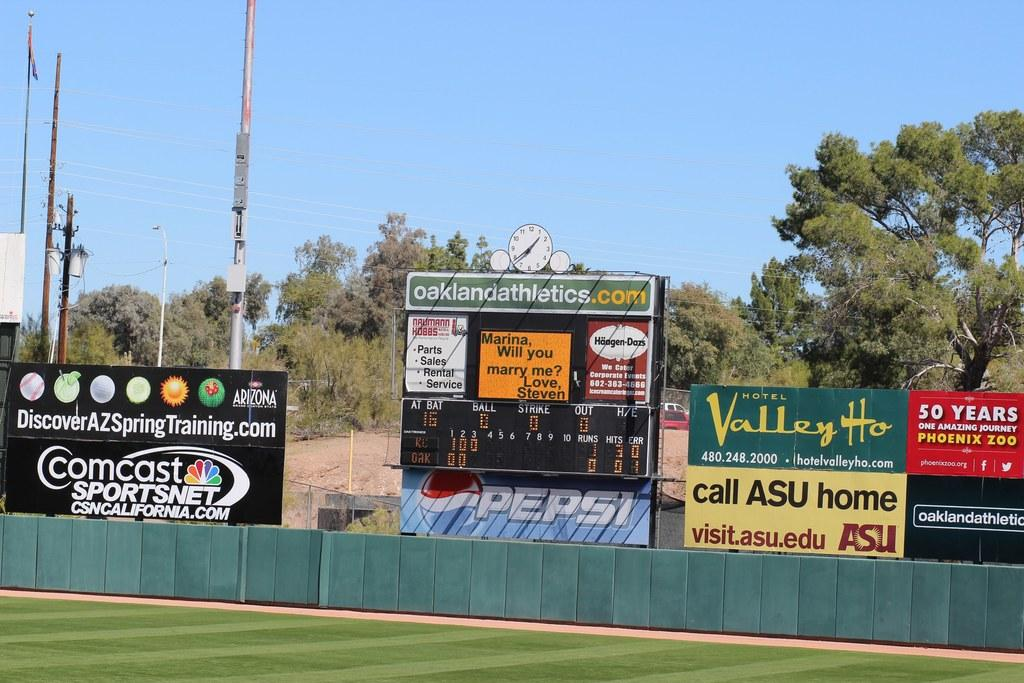<image>
Give a short and clear explanation of the subsequent image. A baseball outfield fence in front of a scoreboard with an oaklandathletics.com sign on it with other signs such as Valley Ho and Comcast Sportsnet nearby. 